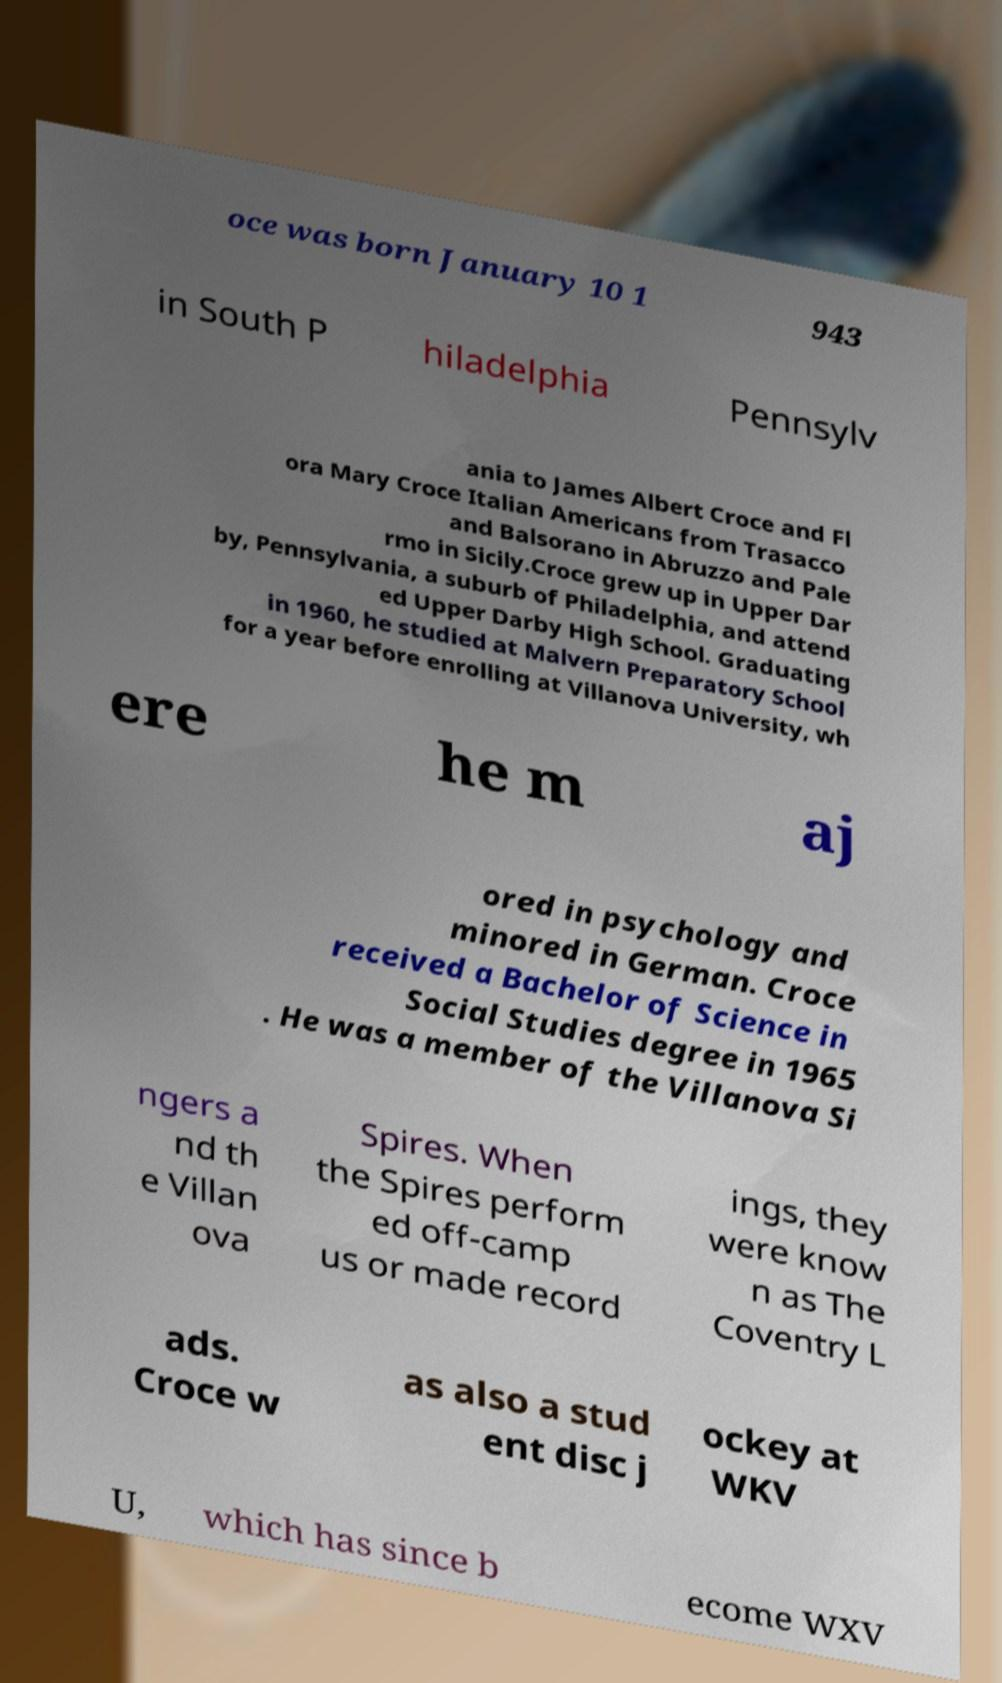I need the written content from this picture converted into text. Can you do that? oce was born January 10 1 943 in South P hiladelphia Pennsylv ania to James Albert Croce and Fl ora Mary Croce Italian Americans from Trasacco and Balsorano in Abruzzo and Pale rmo in Sicily.Croce grew up in Upper Dar by, Pennsylvania, a suburb of Philadelphia, and attend ed Upper Darby High School. Graduating in 1960, he studied at Malvern Preparatory School for a year before enrolling at Villanova University, wh ere he m aj ored in psychology and minored in German. Croce received a Bachelor of Science in Social Studies degree in 1965 . He was a member of the Villanova Si ngers a nd th e Villan ova Spires. When the Spires perform ed off-camp us or made record ings, they were know n as The Coventry L ads. Croce w as also a stud ent disc j ockey at WKV U, which has since b ecome WXV 